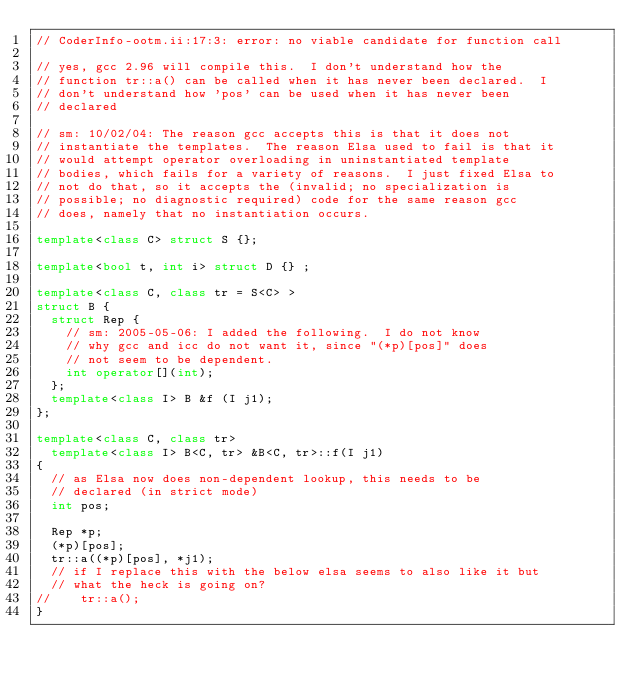Convert code to text. <code><loc_0><loc_0><loc_500><loc_500><_C++_>// CoderInfo-ootm.ii:17:3: error: no viable candidate for function call

// yes, gcc 2.96 will compile this.  I don't understand how the
// function tr::a() can be called when it has never been declared.  I
// don't understand how 'pos' can be used when it has never been
// declared

// sm: 10/02/04: The reason gcc accepts this is that it does not
// instantiate the templates.  The reason Elsa used to fail is that it
// would attempt operator overloading in uninstantiated template
// bodies, which fails for a variety of reasons.  I just fixed Elsa to
// not do that, so it accepts the (invalid; no specialization is
// possible; no diagnostic required) code for the same reason gcc
// does, namely that no instantiation occurs.

template<class C> struct S {};

template<bool t, int i> struct D {} ;

template<class C, class tr = S<C> >
struct B {
  struct Rep {               
    // sm: 2005-05-06: I added the following.  I do not know
    // why gcc and icc do not want it, since "(*p)[pos]" does
    // not seem to be dependent.
    int operator[](int);
  };
  template<class I> B &f (I j1);
};

template<class C, class tr>
  template<class I> B<C, tr> &B<C, tr>::f(I j1)
{
  // as Elsa now does non-dependent lookup, this needs to be
  // declared (in strict mode)
  int pos;

  Rep *p;
  (*p)[pos];
  tr::a((*p)[pos], *j1);
  // if I replace this with the below elsa seems to also like it but
  // what the heck is going on?
//    tr::a();
}
</code> 